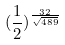<formula> <loc_0><loc_0><loc_500><loc_500>( \frac { 1 } { 2 } ) ^ { \frac { 3 2 } { \sqrt { 4 8 9 } } }</formula> 